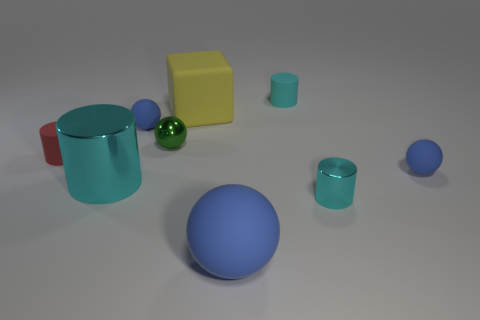How many cubes are either big matte things or big metal objects?
Your response must be concise. 1. Are there any other things that have the same shape as the small red rubber object?
Ensure brevity in your answer.  Yes. Is the number of tiny balls in front of the tiny red rubber cylinder greater than the number of tiny red rubber things on the left side of the big shiny cylinder?
Make the answer very short. No. What number of tiny cylinders are in front of the rubber cylinder that is right of the large cyan metallic object?
Offer a terse response. 2. How many things are either blue matte objects or big purple metallic objects?
Offer a terse response. 3. Is the shape of the large metal thing the same as the small cyan matte thing?
Offer a very short reply. Yes. What is the material of the big cyan cylinder?
Provide a succinct answer. Metal. What number of blue spheres are both in front of the large cyan metallic thing and behind the big metallic cylinder?
Your answer should be compact. 0. Is the green ball the same size as the matte block?
Provide a short and direct response. No. There is a shiny thing left of the green metallic thing; is its size the same as the yellow cube?
Give a very brief answer. Yes. 